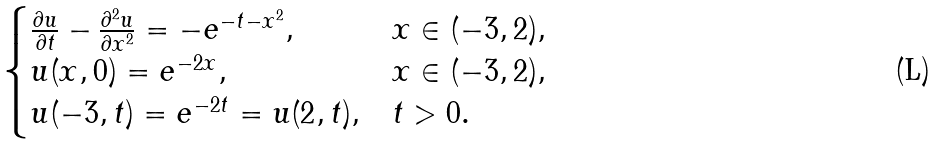Convert formula to latex. <formula><loc_0><loc_0><loc_500><loc_500>\begin{cases} \frac { \partial u } { \partial t } - \frac { \partial ^ { 2 } u } { \partial x ^ { 2 } } = - e ^ { - t - x ^ { 2 } } , & x \in ( - 3 , 2 ) , \\ u ( x , 0 ) = e ^ { - 2 x } , & x \in ( - 3 , 2 ) , \\ u ( - 3 , t ) = e ^ { - 2 t } = u ( 2 , t ) , & t > 0 . \end{cases}</formula> 